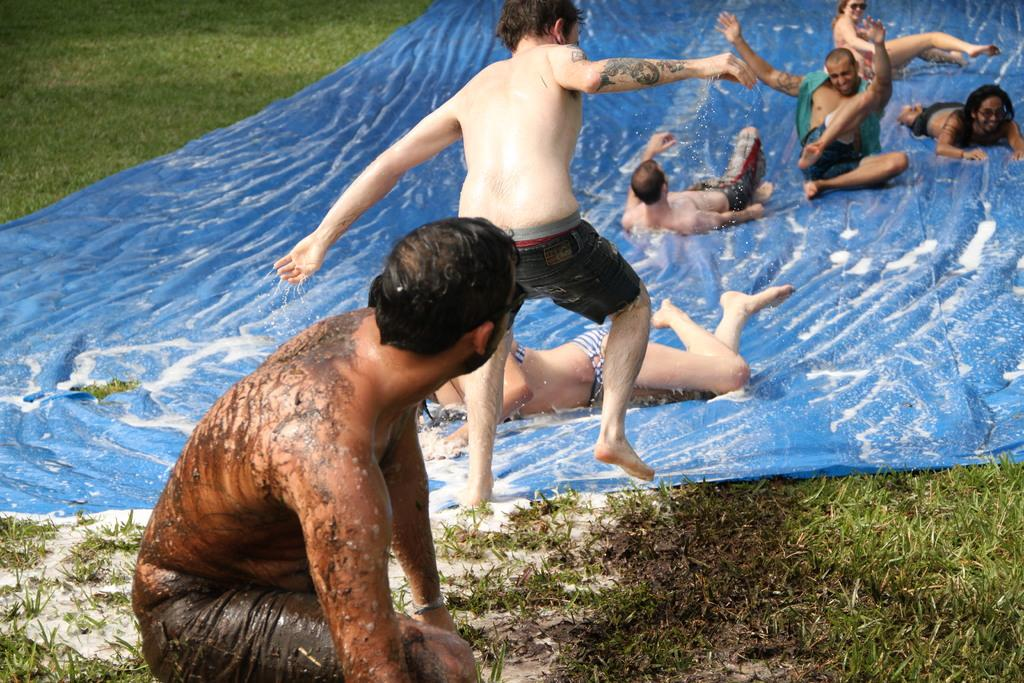How many people are in the group visible in the image? There is a group of people in the image, but the exact number is not specified. What color is the cover in the image? There is a blue cover in the image. What is on top of the blue cover? There is water on the blue cover. What type of natural environment can be seen in the background of the image? There is grass visible in the background of the image. What type of bear is serving the group of people in the image? There is no bear present in the image, and therefore no serving is taking place. 